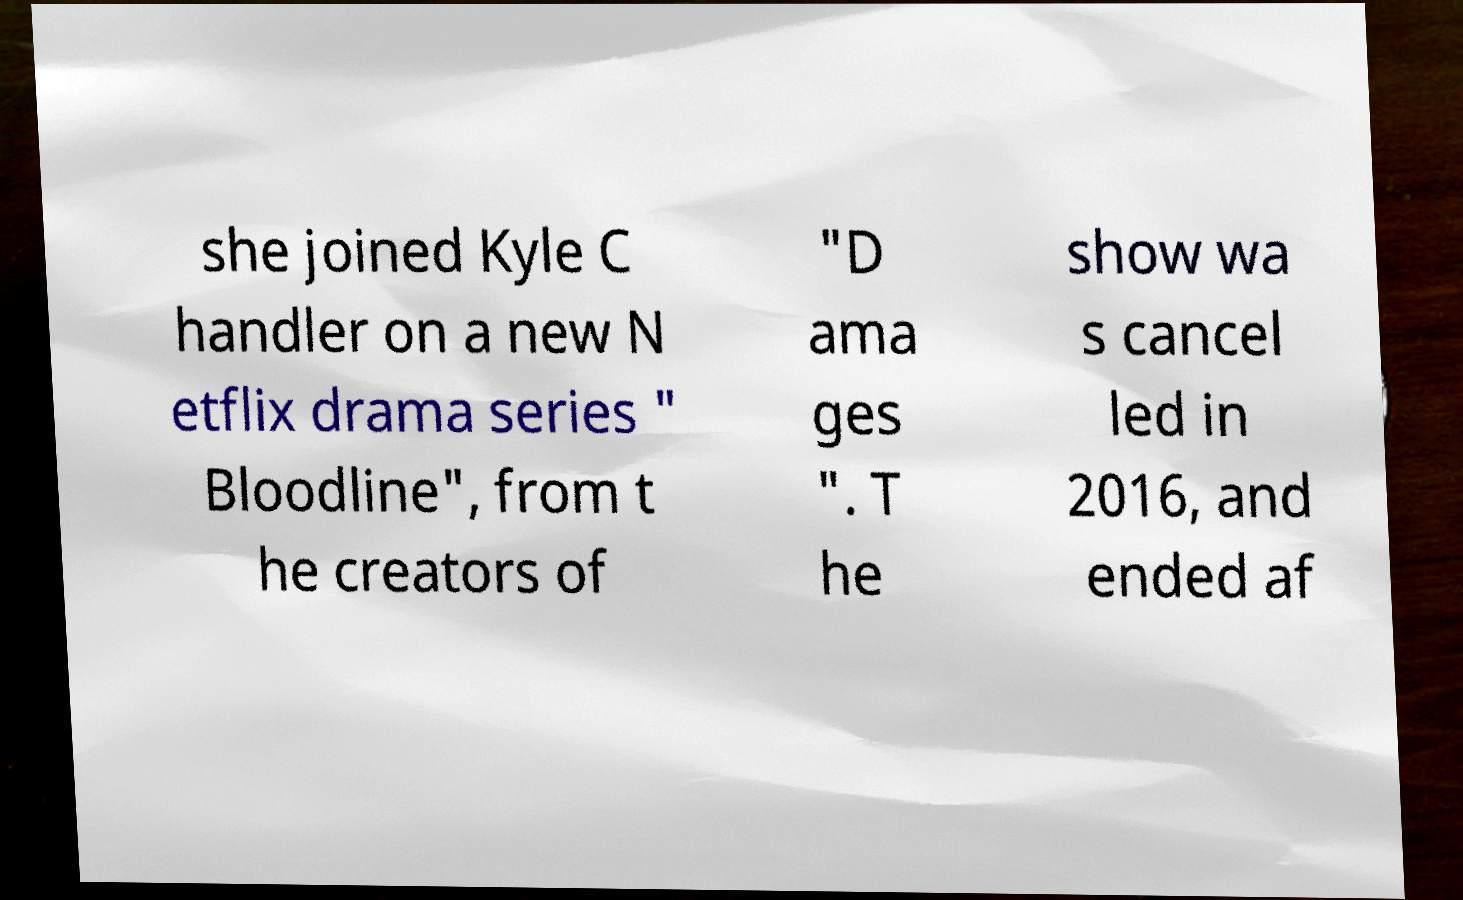There's text embedded in this image that I need extracted. Can you transcribe it verbatim? she joined Kyle C handler on a new N etflix drama series " Bloodline", from t he creators of "D ama ges ". T he show wa s cancel led in 2016, and ended af 